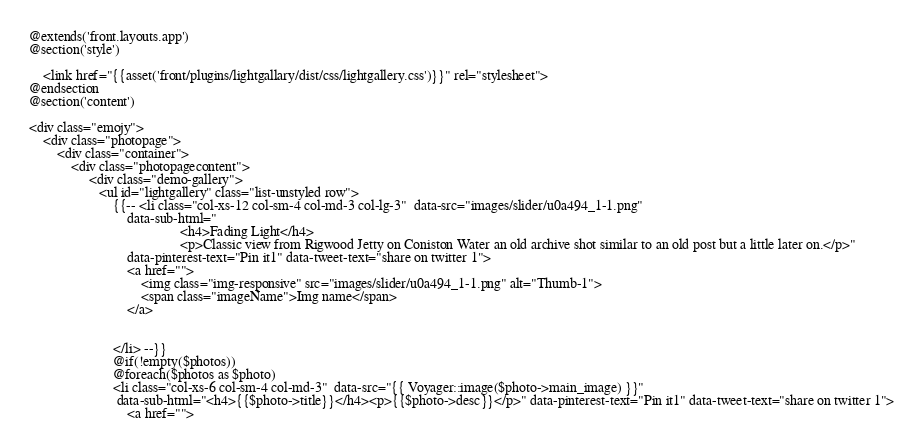Convert code to text. <code><loc_0><loc_0><loc_500><loc_500><_PHP_>@extends('front.layouts.app')
@section('style')

    <link href="{{asset('front/plugins/lightgallary/dist/css/lightgallery.css')}}" rel="stylesheet">
@endsection
@section('content')

<div class="emojy">
    <div class="photopage">
        <div class="container">
            <div class="photopagecontent">
                 <div class="demo-gallery">
                    <ul id="lightgallery" class="list-unstyled row">
                        {{-- <li class="col-xs-12 col-sm-4 col-md-3 col-lg-3"  data-src="images/slider/u0a494_1-1.png"
                            data-sub-html="
                                           <h4>Fading Light</h4>
                                           <p>Classic view from Rigwood Jetty on Coniston Water an old archive shot similar to an old post but a little later on.</p>"
                            data-pinterest-text="Pin it1" data-tweet-text="share on twitter 1">
                            <a href="">
                                <img class="img-responsive" src="images/slider/u0a494_1-1.png" alt="Thumb-1">
                                <span class="imageName">Img name</span>
                            </a>
                            
                            
                        </li> --}}
                        @if(!empty($photos))
                        @foreach($photos as $photo)
                        <li class="col-xs-6 col-sm-4 col-md-3"  data-src="{{ Voyager::image($photo->main_image) }}"
                         data-sub-html="<h4>{{$photo->title}}</h4><p>{{$photo->desc}}</p>" data-pinterest-text="Pin it1" data-tweet-text="share on twitter 1">
                            <a href=""></code> 